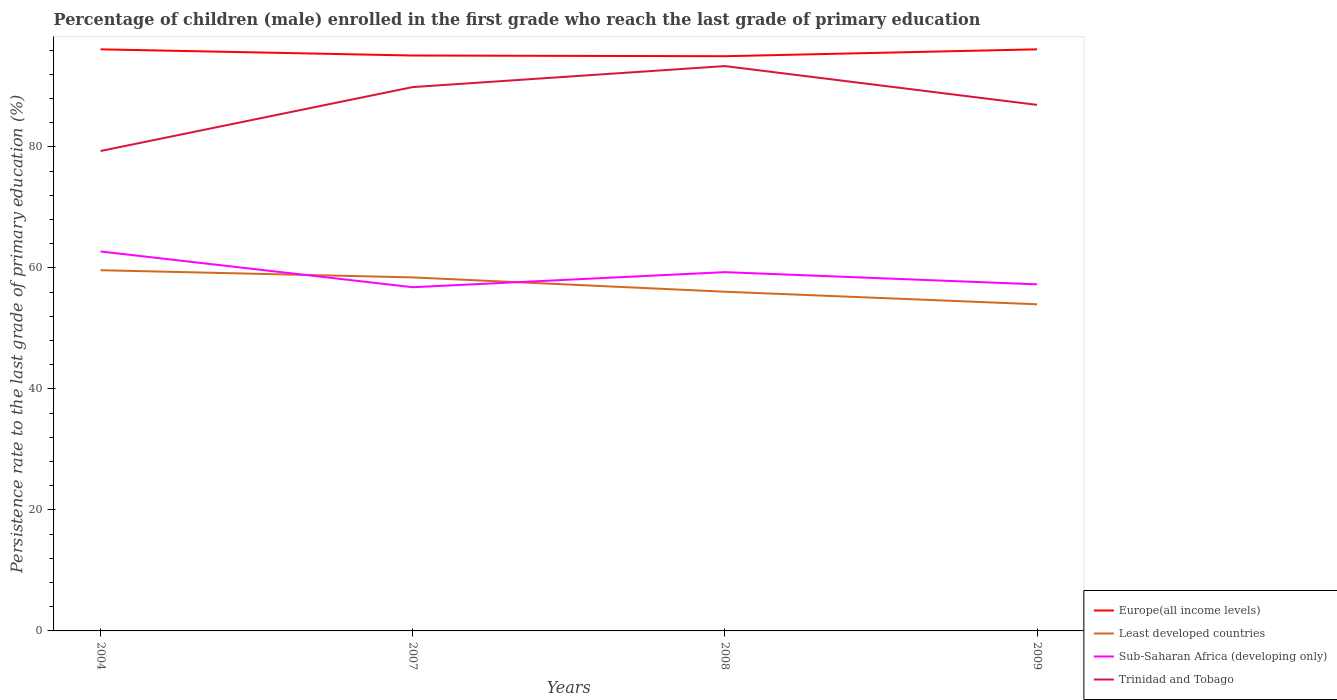Does the line corresponding to Least developed countries intersect with the line corresponding to Sub-Saharan Africa (developing only)?
Offer a very short reply. Yes. Across all years, what is the maximum persistence rate of children in Europe(all income levels)?
Keep it short and to the point. 94.98. In which year was the persistence rate of children in Least developed countries maximum?
Your response must be concise. 2009. What is the total persistence rate of children in Europe(all income levels) in the graph?
Offer a terse response. -1.14. What is the difference between the highest and the second highest persistence rate of children in Trinidad and Tobago?
Make the answer very short. 14.03. Is the persistence rate of children in Sub-Saharan Africa (developing only) strictly greater than the persistence rate of children in Europe(all income levels) over the years?
Provide a short and direct response. Yes. How many years are there in the graph?
Provide a short and direct response. 4. What is the difference between two consecutive major ticks on the Y-axis?
Offer a terse response. 20. Are the values on the major ticks of Y-axis written in scientific E-notation?
Offer a very short reply. No. Does the graph contain any zero values?
Offer a very short reply. No. What is the title of the graph?
Offer a terse response. Percentage of children (male) enrolled in the first grade who reach the last grade of primary education. Does "Andorra" appear as one of the legend labels in the graph?
Your answer should be very brief. No. What is the label or title of the Y-axis?
Your answer should be very brief. Persistence rate to the last grade of primary education (%). What is the Persistence rate to the last grade of primary education (%) of Europe(all income levels) in 2004?
Provide a succinct answer. 96.11. What is the Persistence rate to the last grade of primary education (%) in Least developed countries in 2004?
Give a very brief answer. 59.61. What is the Persistence rate to the last grade of primary education (%) in Sub-Saharan Africa (developing only) in 2004?
Give a very brief answer. 62.71. What is the Persistence rate to the last grade of primary education (%) of Trinidad and Tobago in 2004?
Make the answer very short. 79.31. What is the Persistence rate to the last grade of primary education (%) in Europe(all income levels) in 2007?
Offer a very short reply. 95.09. What is the Persistence rate to the last grade of primary education (%) in Least developed countries in 2007?
Your response must be concise. 58.42. What is the Persistence rate to the last grade of primary education (%) in Sub-Saharan Africa (developing only) in 2007?
Provide a succinct answer. 56.8. What is the Persistence rate to the last grade of primary education (%) of Trinidad and Tobago in 2007?
Give a very brief answer. 89.88. What is the Persistence rate to the last grade of primary education (%) of Europe(all income levels) in 2008?
Keep it short and to the point. 94.98. What is the Persistence rate to the last grade of primary education (%) in Least developed countries in 2008?
Your answer should be very brief. 56.06. What is the Persistence rate to the last grade of primary education (%) in Sub-Saharan Africa (developing only) in 2008?
Offer a very short reply. 59.29. What is the Persistence rate to the last grade of primary education (%) of Trinidad and Tobago in 2008?
Give a very brief answer. 93.35. What is the Persistence rate to the last grade of primary education (%) of Europe(all income levels) in 2009?
Ensure brevity in your answer.  96.11. What is the Persistence rate to the last grade of primary education (%) of Least developed countries in 2009?
Keep it short and to the point. 53.98. What is the Persistence rate to the last grade of primary education (%) in Sub-Saharan Africa (developing only) in 2009?
Your response must be concise. 57.28. What is the Persistence rate to the last grade of primary education (%) of Trinidad and Tobago in 2009?
Your answer should be very brief. 86.94. Across all years, what is the maximum Persistence rate to the last grade of primary education (%) of Europe(all income levels)?
Give a very brief answer. 96.11. Across all years, what is the maximum Persistence rate to the last grade of primary education (%) in Least developed countries?
Offer a very short reply. 59.61. Across all years, what is the maximum Persistence rate to the last grade of primary education (%) of Sub-Saharan Africa (developing only)?
Give a very brief answer. 62.71. Across all years, what is the maximum Persistence rate to the last grade of primary education (%) in Trinidad and Tobago?
Offer a terse response. 93.35. Across all years, what is the minimum Persistence rate to the last grade of primary education (%) in Europe(all income levels)?
Provide a succinct answer. 94.98. Across all years, what is the minimum Persistence rate to the last grade of primary education (%) in Least developed countries?
Offer a terse response. 53.98. Across all years, what is the minimum Persistence rate to the last grade of primary education (%) in Sub-Saharan Africa (developing only)?
Your answer should be very brief. 56.8. Across all years, what is the minimum Persistence rate to the last grade of primary education (%) of Trinidad and Tobago?
Keep it short and to the point. 79.31. What is the total Persistence rate to the last grade of primary education (%) of Europe(all income levels) in the graph?
Your response must be concise. 382.3. What is the total Persistence rate to the last grade of primary education (%) of Least developed countries in the graph?
Your response must be concise. 228.07. What is the total Persistence rate to the last grade of primary education (%) of Sub-Saharan Africa (developing only) in the graph?
Make the answer very short. 236.08. What is the total Persistence rate to the last grade of primary education (%) in Trinidad and Tobago in the graph?
Offer a very short reply. 349.47. What is the difference between the Persistence rate to the last grade of primary education (%) in Europe(all income levels) in 2004 and that in 2007?
Make the answer very short. 1.02. What is the difference between the Persistence rate to the last grade of primary education (%) in Least developed countries in 2004 and that in 2007?
Provide a succinct answer. 1.19. What is the difference between the Persistence rate to the last grade of primary education (%) in Sub-Saharan Africa (developing only) in 2004 and that in 2007?
Ensure brevity in your answer.  5.91. What is the difference between the Persistence rate to the last grade of primary education (%) of Trinidad and Tobago in 2004 and that in 2007?
Make the answer very short. -10.57. What is the difference between the Persistence rate to the last grade of primary education (%) of Europe(all income levels) in 2004 and that in 2008?
Provide a short and direct response. 1.14. What is the difference between the Persistence rate to the last grade of primary education (%) in Least developed countries in 2004 and that in 2008?
Your answer should be compact. 3.56. What is the difference between the Persistence rate to the last grade of primary education (%) in Sub-Saharan Africa (developing only) in 2004 and that in 2008?
Keep it short and to the point. 3.42. What is the difference between the Persistence rate to the last grade of primary education (%) in Trinidad and Tobago in 2004 and that in 2008?
Give a very brief answer. -14.04. What is the difference between the Persistence rate to the last grade of primary education (%) in Europe(all income levels) in 2004 and that in 2009?
Provide a succinct answer. -0. What is the difference between the Persistence rate to the last grade of primary education (%) in Least developed countries in 2004 and that in 2009?
Make the answer very short. 5.63. What is the difference between the Persistence rate to the last grade of primary education (%) in Sub-Saharan Africa (developing only) in 2004 and that in 2009?
Give a very brief answer. 5.43. What is the difference between the Persistence rate to the last grade of primary education (%) of Trinidad and Tobago in 2004 and that in 2009?
Give a very brief answer. -7.62. What is the difference between the Persistence rate to the last grade of primary education (%) in Europe(all income levels) in 2007 and that in 2008?
Make the answer very short. 0.12. What is the difference between the Persistence rate to the last grade of primary education (%) of Least developed countries in 2007 and that in 2008?
Your answer should be compact. 2.37. What is the difference between the Persistence rate to the last grade of primary education (%) of Sub-Saharan Africa (developing only) in 2007 and that in 2008?
Give a very brief answer. -2.49. What is the difference between the Persistence rate to the last grade of primary education (%) of Trinidad and Tobago in 2007 and that in 2008?
Keep it short and to the point. -3.47. What is the difference between the Persistence rate to the last grade of primary education (%) of Europe(all income levels) in 2007 and that in 2009?
Your response must be concise. -1.02. What is the difference between the Persistence rate to the last grade of primary education (%) in Least developed countries in 2007 and that in 2009?
Provide a succinct answer. 4.44. What is the difference between the Persistence rate to the last grade of primary education (%) in Sub-Saharan Africa (developing only) in 2007 and that in 2009?
Give a very brief answer. -0.48. What is the difference between the Persistence rate to the last grade of primary education (%) in Trinidad and Tobago in 2007 and that in 2009?
Your answer should be compact. 2.94. What is the difference between the Persistence rate to the last grade of primary education (%) of Europe(all income levels) in 2008 and that in 2009?
Keep it short and to the point. -1.14. What is the difference between the Persistence rate to the last grade of primary education (%) in Least developed countries in 2008 and that in 2009?
Ensure brevity in your answer.  2.08. What is the difference between the Persistence rate to the last grade of primary education (%) of Sub-Saharan Africa (developing only) in 2008 and that in 2009?
Your response must be concise. 2.02. What is the difference between the Persistence rate to the last grade of primary education (%) in Trinidad and Tobago in 2008 and that in 2009?
Offer a very short reply. 6.41. What is the difference between the Persistence rate to the last grade of primary education (%) of Europe(all income levels) in 2004 and the Persistence rate to the last grade of primary education (%) of Least developed countries in 2007?
Your answer should be very brief. 37.69. What is the difference between the Persistence rate to the last grade of primary education (%) in Europe(all income levels) in 2004 and the Persistence rate to the last grade of primary education (%) in Sub-Saharan Africa (developing only) in 2007?
Ensure brevity in your answer.  39.31. What is the difference between the Persistence rate to the last grade of primary education (%) of Europe(all income levels) in 2004 and the Persistence rate to the last grade of primary education (%) of Trinidad and Tobago in 2007?
Your answer should be compact. 6.24. What is the difference between the Persistence rate to the last grade of primary education (%) in Least developed countries in 2004 and the Persistence rate to the last grade of primary education (%) in Sub-Saharan Africa (developing only) in 2007?
Your answer should be compact. 2.81. What is the difference between the Persistence rate to the last grade of primary education (%) in Least developed countries in 2004 and the Persistence rate to the last grade of primary education (%) in Trinidad and Tobago in 2007?
Offer a very short reply. -30.26. What is the difference between the Persistence rate to the last grade of primary education (%) in Sub-Saharan Africa (developing only) in 2004 and the Persistence rate to the last grade of primary education (%) in Trinidad and Tobago in 2007?
Keep it short and to the point. -27.17. What is the difference between the Persistence rate to the last grade of primary education (%) of Europe(all income levels) in 2004 and the Persistence rate to the last grade of primary education (%) of Least developed countries in 2008?
Give a very brief answer. 40.06. What is the difference between the Persistence rate to the last grade of primary education (%) in Europe(all income levels) in 2004 and the Persistence rate to the last grade of primary education (%) in Sub-Saharan Africa (developing only) in 2008?
Keep it short and to the point. 36.82. What is the difference between the Persistence rate to the last grade of primary education (%) of Europe(all income levels) in 2004 and the Persistence rate to the last grade of primary education (%) of Trinidad and Tobago in 2008?
Ensure brevity in your answer.  2.77. What is the difference between the Persistence rate to the last grade of primary education (%) of Least developed countries in 2004 and the Persistence rate to the last grade of primary education (%) of Sub-Saharan Africa (developing only) in 2008?
Offer a very short reply. 0.32. What is the difference between the Persistence rate to the last grade of primary education (%) in Least developed countries in 2004 and the Persistence rate to the last grade of primary education (%) in Trinidad and Tobago in 2008?
Provide a succinct answer. -33.73. What is the difference between the Persistence rate to the last grade of primary education (%) in Sub-Saharan Africa (developing only) in 2004 and the Persistence rate to the last grade of primary education (%) in Trinidad and Tobago in 2008?
Keep it short and to the point. -30.64. What is the difference between the Persistence rate to the last grade of primary education (%) of Europe(all income levels) in 2004 and the Persistence rate to the last grade of primary education (%) of Least developed countries in 2009?
Keep it short and to the point. 42.13. What is the difference between the Persistence rate to the last grade of primary education (%) of Europe(all income levels) in 2004 and the Persistence rate to the last grade of primary education (%) of Sub-Saharan Africa (developing only) in 2009?
Your answer should be compact. 38.84. What is the difference between the Persistence rate to the last grade of primary education (%) in Europe(all income levels) in 2004 and the Persistence rate to the last grade of primary education (%) in Trinidad and Tobago in 2009?
Ensure brevity in your answer.  9.18. What is the difference between the Persistence rate to the last grade of primary education (%) of Least developed countries in 2004 and the Persistence rate to the last grade of primary education (%) of Sub-Saharan Africa (developing only) in 2009?
Keep it short and to the point. 2.34. What is the difference between the Persistence rate to the last grade of primary education (%) of Least developed countries in 2004 and the Persistence rate to the last grade of primary education (%) of Trinidad and Tobago in 2009?
Offer a very short reply. -27.32. What is the difference between the Persistence rate to the last grade of primary education (%) of Sub-Saharan Africa (developing only) in 2004 and the Persistence rate to the last grade of primary education (%) of Trinidad and Tobago in 2009?
Your answer should be compact. -24.23. What is the difference between the Persistence rate to the last grade of primary education (%) of Europe(all income levels) in 2007 and the Persistence rate to the last grade of primary education (%) of Least developed countries in 2008?
Your response must be concise. 39.04. What is the difference between the Persistence rate to the last grade of primary education (%) in Europe(all income levels) in 2007 and the Persistence rate to the last grade of primary education (%) in Sub-Saharan Africa (developing only) in 2008?
Make the answer very short. 35.8. What is the difference between the Persistence rate to the last grade of primary education (%) in Europe(all income levels) in 2007 and the Persistence rate to the last grade of primary education (%) in Trinidad and Tobago in 2008?
Your answer should be compact. 1.75. What is the difference between the Persistence rate to the last grade of primary education (%) of Least developed countries in 2007 and the Persistence rate to the last grade of primary education (%) of Sub-Saharan Africa (developing only) in 2008?
Keep it short and to the point. -0.87. What is the difference between the Persistence rate to the last grade of primary education (%) of Least developed countries in 2007 and the Persistence rate to the last grade of primary education (%) of Trinidad and Tobago in 2008?
Offer a terse response. -34.92. What is the difference between the Persistence rate to the last grade of primary education (%) of Sub-Saharan Africa (developing only) in 2007 and the Persistence rate to the last grade of primary education (%) of Trinidad and Tobago in 2008?
Ensure brevity in your answer.  -36.55. What is the difference between the Persistence rate to the last grade of primary education (%) in Europe(all income levels) in 2007 and the Persistence rate to the last grade of primary education (%) in Least developed countries in 2009?
Provide a short and direct response. 41.11. What is the difference between the Persistence rate to the last grade of primary education (%) in Europe(all income levels) in 2007 and the Persistence rate to the last grade of primary education (%) in Sub-Saharan Africa (developing only) in 2009?
Give a very brief answer. 37.82. What is the difference between the Persistence rate to the last grade of primary education (%) of Europe(all income levels) in 2007 and the Persistence rate to the last grade of primary education (%) of Trinidad and Tobago in 2009?
Your answer should be very brief. 8.16. What is the difference between the Persistence rate to the last grade of primary education (%) in Least developed countries in 2007 and the Persistence rate to the last grade of primary education (%) in Sub-Saharan Africa (developing only) in 2009?
Offer a very short reply. 1.15. What is the difference between the Persistence rate to the last grade of primary education (%) in Least developed countries in 2007 and the Persistence rate to the last grade of primary education (%) in Trinidad and Tobago in 2009?
Your answer should be compact. -28.51. What is the difference between the Persistence rate to the last grade of primary education (%) in Sub-Saharan Africa (developing only) in 2007 and the Persistence rate to the last grade of primary education (%) in Trinidad and Tobago in 2009?
Your answer should be compact. -30.14. What is the difference between the Persistence rate to the last grade of primary education (%) of Europe(all income levels) in 2008 and the Persistence rate to the last grade of primary education (%) of Least developed countries in 2009?
Keep it short and to the point. 41. What is the difference between the Persistence rate to the last grade of primary education (%) of Europe(all income levels) in 2008 and the Persistence rate to the last grade of primary education (%) of Sub-Saharan Africa (developing only) in 2009?
Your response must be concise. 37.7. What is the difference between the Persistence rate to the last grade of primary education (%) of Europe(all income levels) in 2008 and the Persistence rate to the last grade of primary education (%) of Trinidad and Tobago in 2009?
Keep it short and to the point. 8.04. What is the difference between the Persistence rate to the last grade of primary education (%) of Least developed countries in 2008 and the Persistence rate to the last grade of primary education (%) of Sub-Saharan Africa (developing only) in 2009?
Your response must be concise. -1.22. What is the difference between the Persistence rate to the last grade of primary education (%) in Least developed countries in 2008 and the Persistence rate to the last grade of primary education (%) in Trinidad and Tobago in 2009?
Offer a terse response. -30.88. What is the difference between the Persistence rate to the last grade of primary education (%) in Sub-Saharan Africa (developing only) in 2008 and the Persistence rate to the last grade of primary education (%) in Trinidad and Tobago in 2009?
Keep it short and to the point. -27.64. What is the average Persistence rate to the last grade of primary education (%) in Europe(all income levels) per year?
Keep it short and to the point. 95.57. What is the average Persistence rate to the last grade of primary education (%) of Least developed countries per year?
Ensure brevity in your answer.  57.02. What is the average Persistence rate to the last grade of primary education (%) in Sub-Saharan Africa (developing only) per year?
Offer a terse response. 59.02. What is the average Persistence rate to the last grade of primary education (%) of Trinidad and Tobago per year?
Your answer should be very brief. 87.37. In the year 2004, what is the difference between the Persistence rate to the last grade of primary education (%) in Europe(all income levels) and Persistence rate to the last grade of primary education (%) in Least developed countries?
Ensure brevity in your answer.  36.5. In the year 2004, what is the difference between the Persistence rate to the last grade of primary education (%) in Europe(all income levels) and Persistence rate to the last grade of primary education (%) in Sub-Saharan Africa (developing only)?
Keep it short and to the point. 33.4. In the year 2004, what is the difference between the Persistence rate to the last grade of primary education (%) in Europe(all income levels) and Persistence rate to the last grade of primary education (%) in Trinidad and Tobago?
Your answer should be compact. 16.8. In the year 2004, what is the difference between the Persistence rate to the last grade of primary education (%) in Least developed countries and Persistence rate to the last grade of primary education (%) in Sub-Saharan Africa (developing only)?
Provide a succinct answer. -3.1. In the year 2004, what is the difference between the Persistence rate to the last grade of primary education (%) in Least developed countries and Persistence rate to the last grade of primary education (%) in Trinidad and Tobago?
Ensure brevity in your answer.  -19.7. In the year 2004, what is the difference between the Persistence rate to the last grade of primary education (%) of Sub-Saharan Africa (developing only) and Persistence rate to the last grade of primary education (%) of Trinidad and Tobago?
Your response must be concise. -16.6. In the year 2007, what is the difference between the Persistence rate to the last grade of primary education (%) in Europe(all income levels) and Persistence rate to the last grade of primary education (%) in Least developed countries?
Make the answer very short. 36.67. In the year 2007, what is the difference between the Persistence rate to the last grade of primary education (%) of Europe(all income levels) and Persistence rate to the last grade of primary education (%) of Sub-Saharan Africa (developing only)?
Make the answer very short. 38.29. In the year 2007, what is the difference between the Persistence rate to the last grade of primary education (%) of Europe(all income levels) and Persistence rate to the last grade of primary education (%) of Trinidad and Tobago?
Keep it short and to the point. 5.22. In the year 2007, what is the difference between the Persistence rate to the last grade of primary education (%) of Least developed countries and Persistence rate to the last grade of primary education (%) of Sub-Saharan Africa (developing only)?
Offer a terse response. 1.62. In the year 2007, what is the difference between the Persistence rate to the last grade of primary education (%) in Least developed countries and Persistence rate to the last grade of primary education (%) in Trinidad and Tobago?
Your answer should be compact. -31.45. In the year 2007, what is the difference between the Persistence rate to the last grade of primary education (%) of Sub-Saharan Africa (developing only) and Persistence rate to the last grade of primary education (%) of Trinidad and Tobago?
Offer a terse response. -33.08. In the year 2008, what is the difference between the Persistence rate to the last grade of primary education (%) in Europe(all income levels) and Persistence rate to the last grade of primary education (%) in Least developed countries?
Offer a very short reply. 38.92. In the year 2008, what is the difference between the Persistence rate to the last grade of primary education (%) of Europe(all income levels) and Persistence rate to the last grade of primary education (%) of Sub-Saharan Africa (developing only)?
Your response must be concise. 35.68. In the year 2008, what is the difference between the Persistence rate to the last grade of primary education (%) of Europe(all income levels) and Persistence rate to the last grade of primary education (%) of Trinidad and Tobago?
Your answer should be compact. 1.63. In the year 2008, what is the difference between the Persistence rate to the last grade of primary education (%) of Least developed countries and Persistence rate to the last grade of primary education (%) of Sub-Saharan Africa (developing only)?
Provide a short and direct response. -3.24. In the year 2008, what is the difference between the Persistence rate to the last grade of primary education (%) in Least developed countries and Persistence rate to the last grade of primary education (%) in Trinidad and Tobago?
Your answer should be compact. -37.29. In the year 2008, what is the difference between the Persistence rate to the last grade of primary education (%) in Sub-Saharan Africa (developing only) and Persistence rate to the last grade of primary education (%) in Trinidad and Tobago?
Your answer should be very brief. -34.05. In the year 2009, what is the difference between the Persistence rate to the last grade of primary education (%) in Europe(all income levels) and Persistence rate to the last grade of primary education (%) in Least developed countries?
Keep it short and to the point. 42.14. In the year 2009, what is the difference between the Persistence rate to the last grade of primary education (%) in Europe(all income levels) and Persistence rate to the last grade of primary education (%) in Sub-Saharan Africa (developing only)?
Your response must be concise. 38.84. In the year 2009, what is the difference between the Persistence rate to the last grade of primary education (%) in Europe(all income levels) and Persistence rate to the last grade of primary education (%) in Trinidad and Tobago?
Provide a short and direct response. 9.18. In the year 2009, what is the difference between the Persistence rate to the last grade of primary education (%) in Least developed countries and Persistence rate to the last grade of primary education (%) in Sub-Saharan Africa (developing only)?
Offer a terse response. -3.3. In the year 2009, what is the difference between the Persistence rate to the last grade of primary education (%) of Least developed countries and Persistence rate to the last grade of primary education (%) of Trinidad and Tobago?
Ensure brevity in your answer.  -32.96. In the year 2009, what is the difference between the Persistence rate to the last grade of primary education (%) of Sub-Saharan Africa (developing only) and Persistence rate to the last grade of primary education (%) of Trinidad and Tobago?
Offer a terse response. -29.66. What is the ratio of the Persistence rate to the last grade of primary education (%) of Europe(all income levels) in 2004 to that in 2007?
Make the answer very short. 1.01. What is the ratio of the Persistence rate to the last grade of primary education (%) in Least developed countries in 2004 to that in 2007?
Provide a succinct answer. 1.02. What is the ratio of the Persistence rate to the last grade of primary education (%) in Sub-Saharan Africa (developing only) in 2004 to that in 2007?
Offer a very short reply. 1.1. What is the ratio of the Persistence rate to the last grade of primary education (%) of Trinidad and Tobago in 2004 to that in 2007?
Provide a succinct answer. 0.88. What is the ratio of the Persistence rate to the last grade of primary education (%) in Europe(all income levels) in 2004 to that in 2008?
Give a very brief answer. 1.01. What is the ratio of the Persistence rate to the last grade of primary education (%) in Least developed countries in 2004 to that in 2008?
Make the answer very short. 1.06. What is the ratio of the Persistence rate to the last grade of primary education (%) of Sub-Saharan Africa (developing only) in 2004 to that in 2008?
Make the answer very short. 1.06. What is the ratio of the Persistence rate to the last grade of primary education (%) in Trinidad and Tobago in 2004 to that in 2008?
Keep it short and to the point. 0.85. What is the ratio of the Persistence rate to the last grade of primary education (%) of Europe(all income levels) in 2004 to that in 2009?
Your answer should be very brief. 1. What is the ratio of the Persistence rate to the last grade of primary education (%) in Least developed countries in 2004 to that in 2009?
Your answer should be compact. 1.1. What is the ratio of the Persistence rate to the last grade of primary education (%) of Sub-Saharan Africa (developing only) in 2004 to that in 2009?
Offer a very short reply. 1.09. What is the ratio of the Persistence rate to the last grade of primary education (%) of Trinidad and Tobago in 2004 to that in 2009?
Offer a very short reply. 0.91. What is the ratio of the Persistence rate to the last grade of primary education (%) of Least developed countries in 2007 to that in 2008?
Offer a very short reply. 1.04. What is the ratio of the Persistence rate to the last grade of primary education (%) in Sub-Saharan Africa (developing only) in 2007 to that in 2008?
Your response must be concise. 0.96. What is the ratio of the Persistence rate to the last grade of primary education (%) in Trinidad and Tobago in 2007 to that in 2008?
Your answer should be very brief. 0.96. What is the ratio of the Persistence rate to the last grade of primary education (%) of Least developed countries in 2007 to that in 2009?
Provide a succinct answer. 1.08. What is the ratio of the Persistence rate to the last grade of primary education (%) in Sub-Saharan Africa (developing only) in 2007 to that in 2009?
Provide a short and direct response. 0.99. What is the ratio of the Persistence rate to the last grade of primary education (%) of Trinidad and Tobago in 2007 to that in 2009?
Your response must be concise. 1.03. What is the ratio of the Persistence rate to the last grade of primary education (%) of Least developed countries in 2008 to that in 2009?
Provide a short and direct response. 1.04. What is the ratio of the Persistence rate to the last grade of primary education (%) in Sub-Saharan Africa (developing only) in 2008 to that in 2009?
Keep it short and to the point. 1.04. What is the ratio of the Persistence rate to the last grade of primary education (%) of Trinidad and Tobago in 2008 to that in 2009?
Provide a succinct answer. 1.07. What is the difference between the highest and the second highest Persistence rate to the last grade of primary education (%) in Europe(all income levels)?
Your response must be concise. 0. What is the difference between the highest and the second highest Persistence rate to the last grade of primary education (%) in Least developed countries?
Provide a short and direct response. 1.19. What is the difference between the highest and the second highest Persistence rate to the last grade of primary education (%) of Sub-Saharan Africa (developing only)?
Give a very brief answer. 3.42. What is the difference between the highest and the second highest Persistence rate to the last grade of primary education (%) of Trinidad and Tobago?
Keep it short and to the point. 3.47. What is the difference between the highest and the lowest Persistence rate to the last grade of primary education (%) of Europe(all income levels)?
Provide a succinct answer. 1.14. What is the difference between the highest and the lowest Persistence rate to the last grade of primary education (%) of Least developed countries?
Make the answer very short. 5.63. What is the difference between the highest and the lowest Persistence rate to the last grade of primary education (%) in Sub-Saharan Africa (developing only)?
Offer a very short reply. 5.91. What is the difference between the highest and the lowest Persistence rate to the last grade of primary education (%) in Trinidad and Tobago?
Provide a succinct answer. 14.04. 